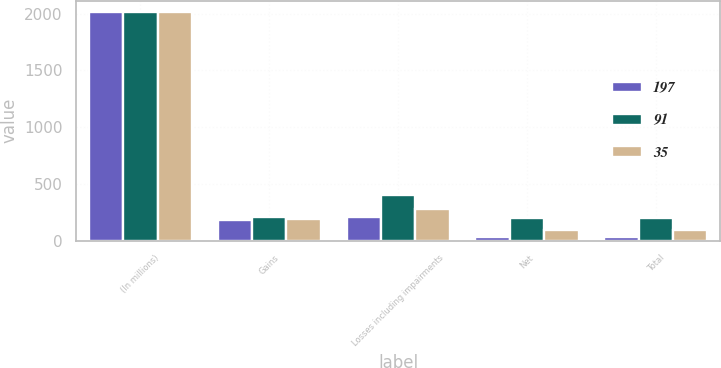Convert chart to OTSL. <chart><loc_0><loc_0><loc_500><loc_500><stacked_bar_chart><ecel><fcel>(In millions)<fcel>Gains<fcel>Losses including impairments<fcel>Net<fcel>Total<nl><fcel>197<fcel>2012<fcel>177<fcel>211<fcel>34<fcel>35<nl><fcel>91<fcel>2011<fcel>205<fcel>402<fcel>197<fcel>197<nl><fcel>35<fcel>2010<fcel>190<fcel>281<fcel>91<fcel>91<nl></chart> 